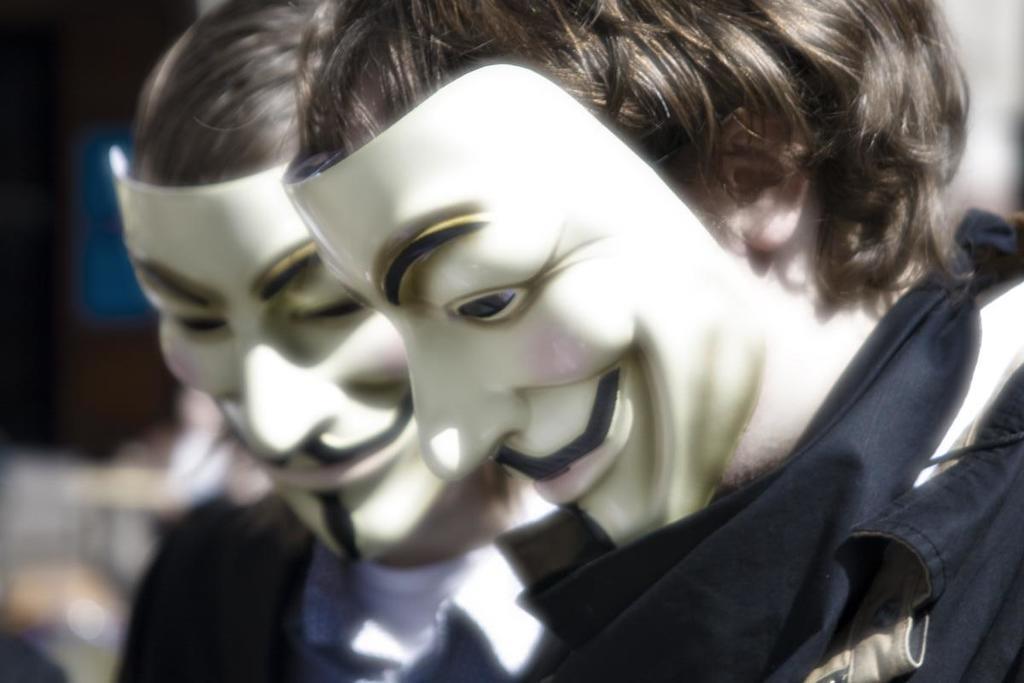Please provide a concise description of this image. In this image I can see two persons. These two persons are wearing masks. The background of the image is blurred. 